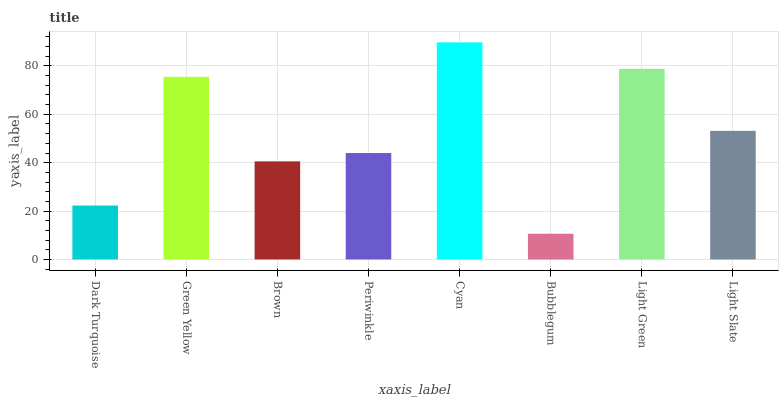Is Green Yellow the minimum?
Answer yes or no. No. Is Green Yellow the maximum?
Answer yes or no. No. Is Green Yellow greater than Dark Turquoise?
Answer yes or no. Yes. Is Dark Turquoise less than Green Yellow?
Answer yes or no. Yes. Is Dark Turquoise greater than Green Yellow?
Answer yes or no. No. Is Green Yellow less than Dark Turquoise?
Answer yes or no. No. Is Light Slate the high median?
Answer yes or no. Yes. Is Periwinkle the low median?
Answer yes or no. Yes. Is Periwinkle the high median?
Answer yes or no. No. Is Cyan the low median?
Answer yes or no. No. 